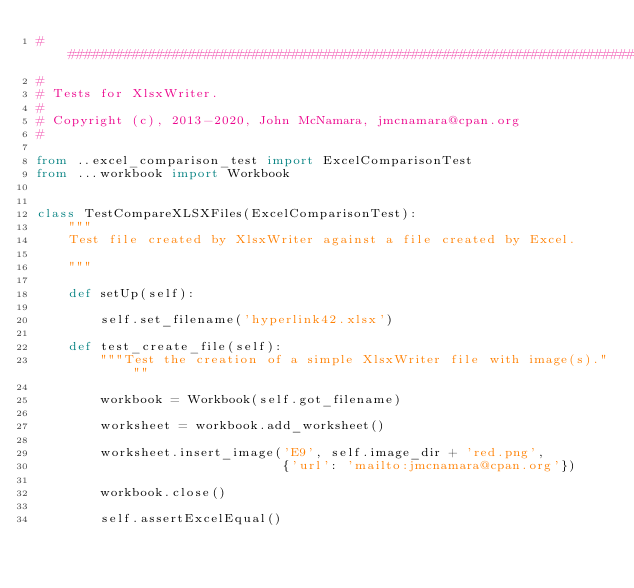<code> <loc_0><loc_0><loc_500><loc_500><_Python_>###############################################################################
#
# Tests for XlsxWriter.
#
# Copyright (c), 2013-2020, John McNamara, jmcnamara@cpan.org
#

from ..excel_comparison_test import ExcelComparisonTest
from ...workbook import Workbook


class TestCompareXLSXFiles(ExcelComparisonTest):
    """
    Test file created by XlsxWriter against a file created by Excel.

    """

    def setUp(self):

        self.set_filename('hyperlink42.xlsx')

    def test_create_file(self):
        """Test the creation of a simple XlsxWriter file with image(s)."""

        workbook = Workbook(self.got_filename)

        worksheet = workbook.add_worksheet()

        worksheet.insert_image('E9', self.image_dir + 'red.png',
                               {'url': 'mailto:jmcnamara@cpan.org'})

        workbook.close()

        self.assertExcelEqual()
</code> 